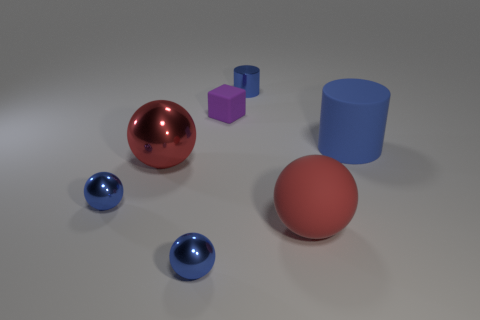Subtract all metallic balls. How many balls are left? 1 Subtract all cyan spheres. Subtract all blue blocks. How many spheres are left? 4 Add 1 big matte balls. How many objects exist? 8 Subtract all spheres. How many objects are left? 3 Add 2 tiny blue metallic balls. How many tiny blue metallic balls exist? 4 Subtract 0 yellow cubes. How many objects are left? 7 Subtract all brown metal cylinders. Subtract all tiny cylinders. How many objects are left? 6 Add 6 red metallic objects. How many red metallic objects are left? 7 